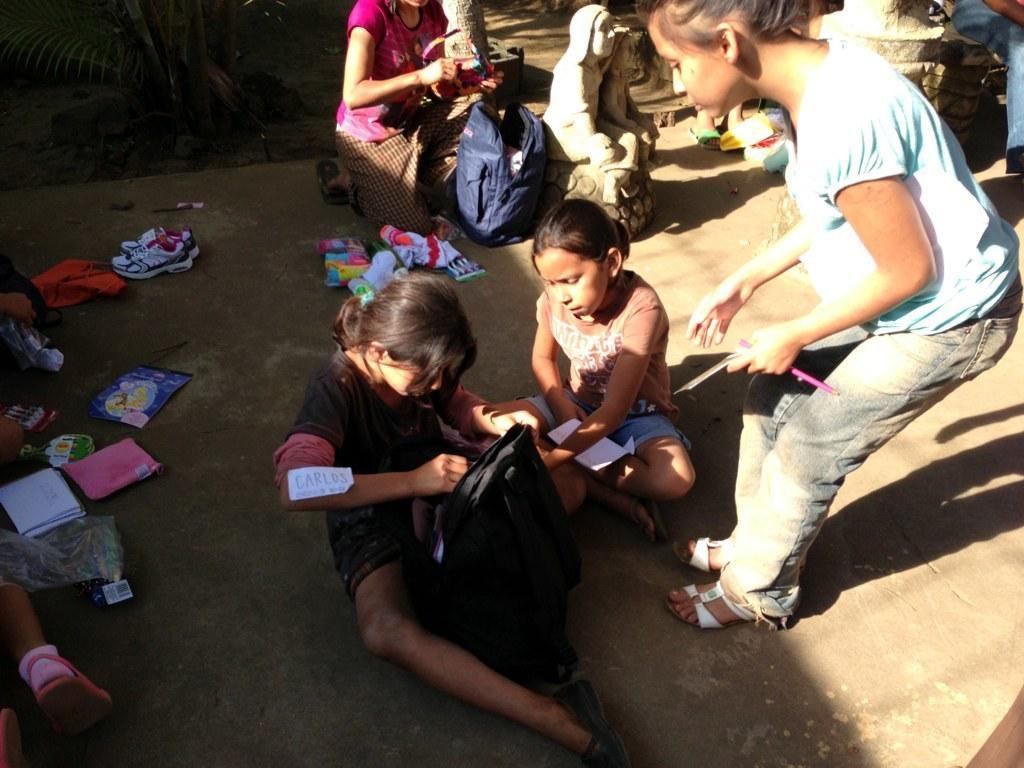How would you summarize this image in a sentence or two? In this picture, we see two girls are sitting on the road. In front of them, we see a black color bag. The girl in blue T-shirt is standing and she is holding a pen and a paper in her hands. Behind them, we see a girl in pink T-shirt is holding something in her hands. In front of her, we see a blue bag and the statue. On the left side, we see papers, books, napkin, shoes and a plastic cover. This picture might be clicked outside the city. It is a sunny day. 